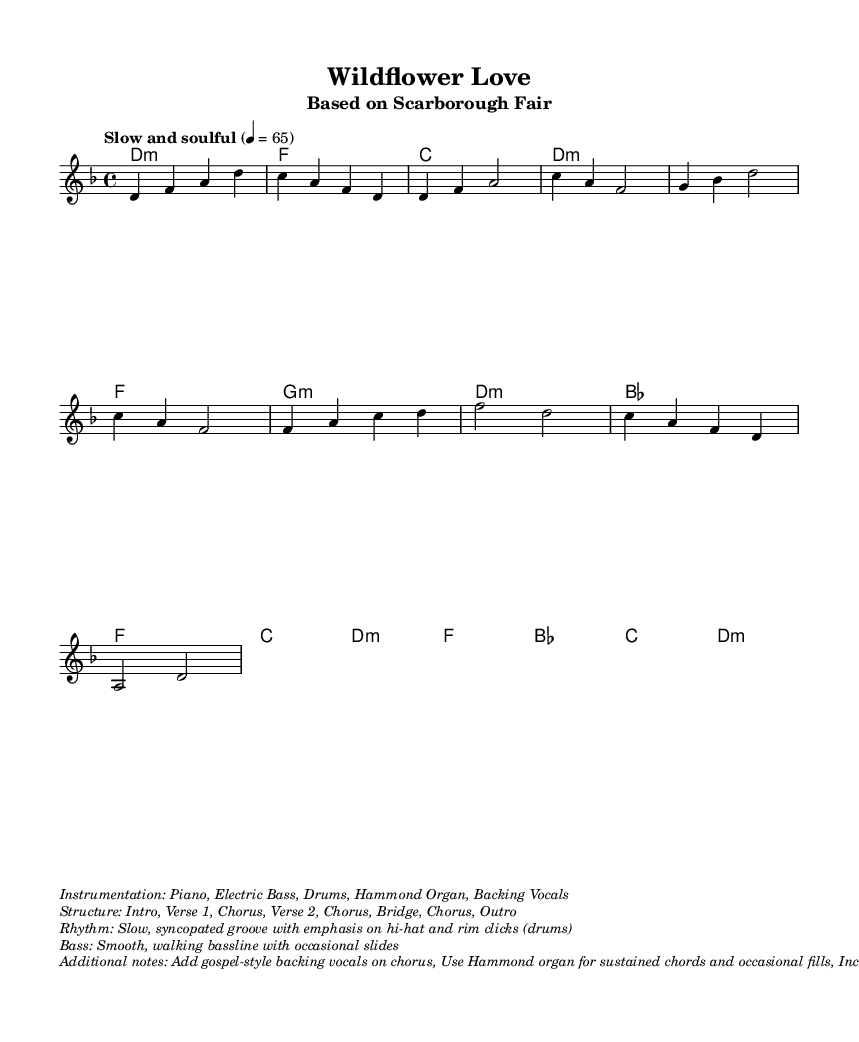What is the key signature of this music? The key signature is D minor, which has one flat (B flat). The key signature is indicated at the beginning of the staff.
Answer: D minor What is the time signature of the piece? The time signature is 4/4, which means there are four beats in each measure. This information is found at the beginning of the music.
Answer: 4/4 What is the tempo marking for the song? The tempo marking indicates a slow and soulful style, depicted in the score with the phrase "Slow and soulful" and a metronome marking of 65.
Answer: Slow and soulful How many verses are in the structure of the song? The structure lists "Verse 1," followed by "Verse 2," indicating that there are two verses in the song's arrangement.
Answer: 2 What instrumentation is specified for this piece? The instrumentation is detailed in the markup section and indicates a combination of instruments, including Piano, Electric Bass, Drums, and Hammond Organ.
Answer: Piano, Electric Bass, Drums, Hammond Organ What style of vocals is suggested for the chorus? The additional notes specify the inclusion of gospel-style backing vocals during the chorus, contributing to the soulful feeling of the piece.
Answer: Gospel-style backing vocals What type of groove is indicated for the rhythm? The rhythm section is described as having a "slow, syncopated groove," highlighting specific drumming techniques such as emphasis on hi-hat and rim clicks.
Answer: Slow, syncopated groove 